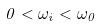Convert formula to latex. <formula><loc_0><loc_0><loc_500><loc_500>0 < \omega _ { i } < \omega _ { 0 }</formula> 